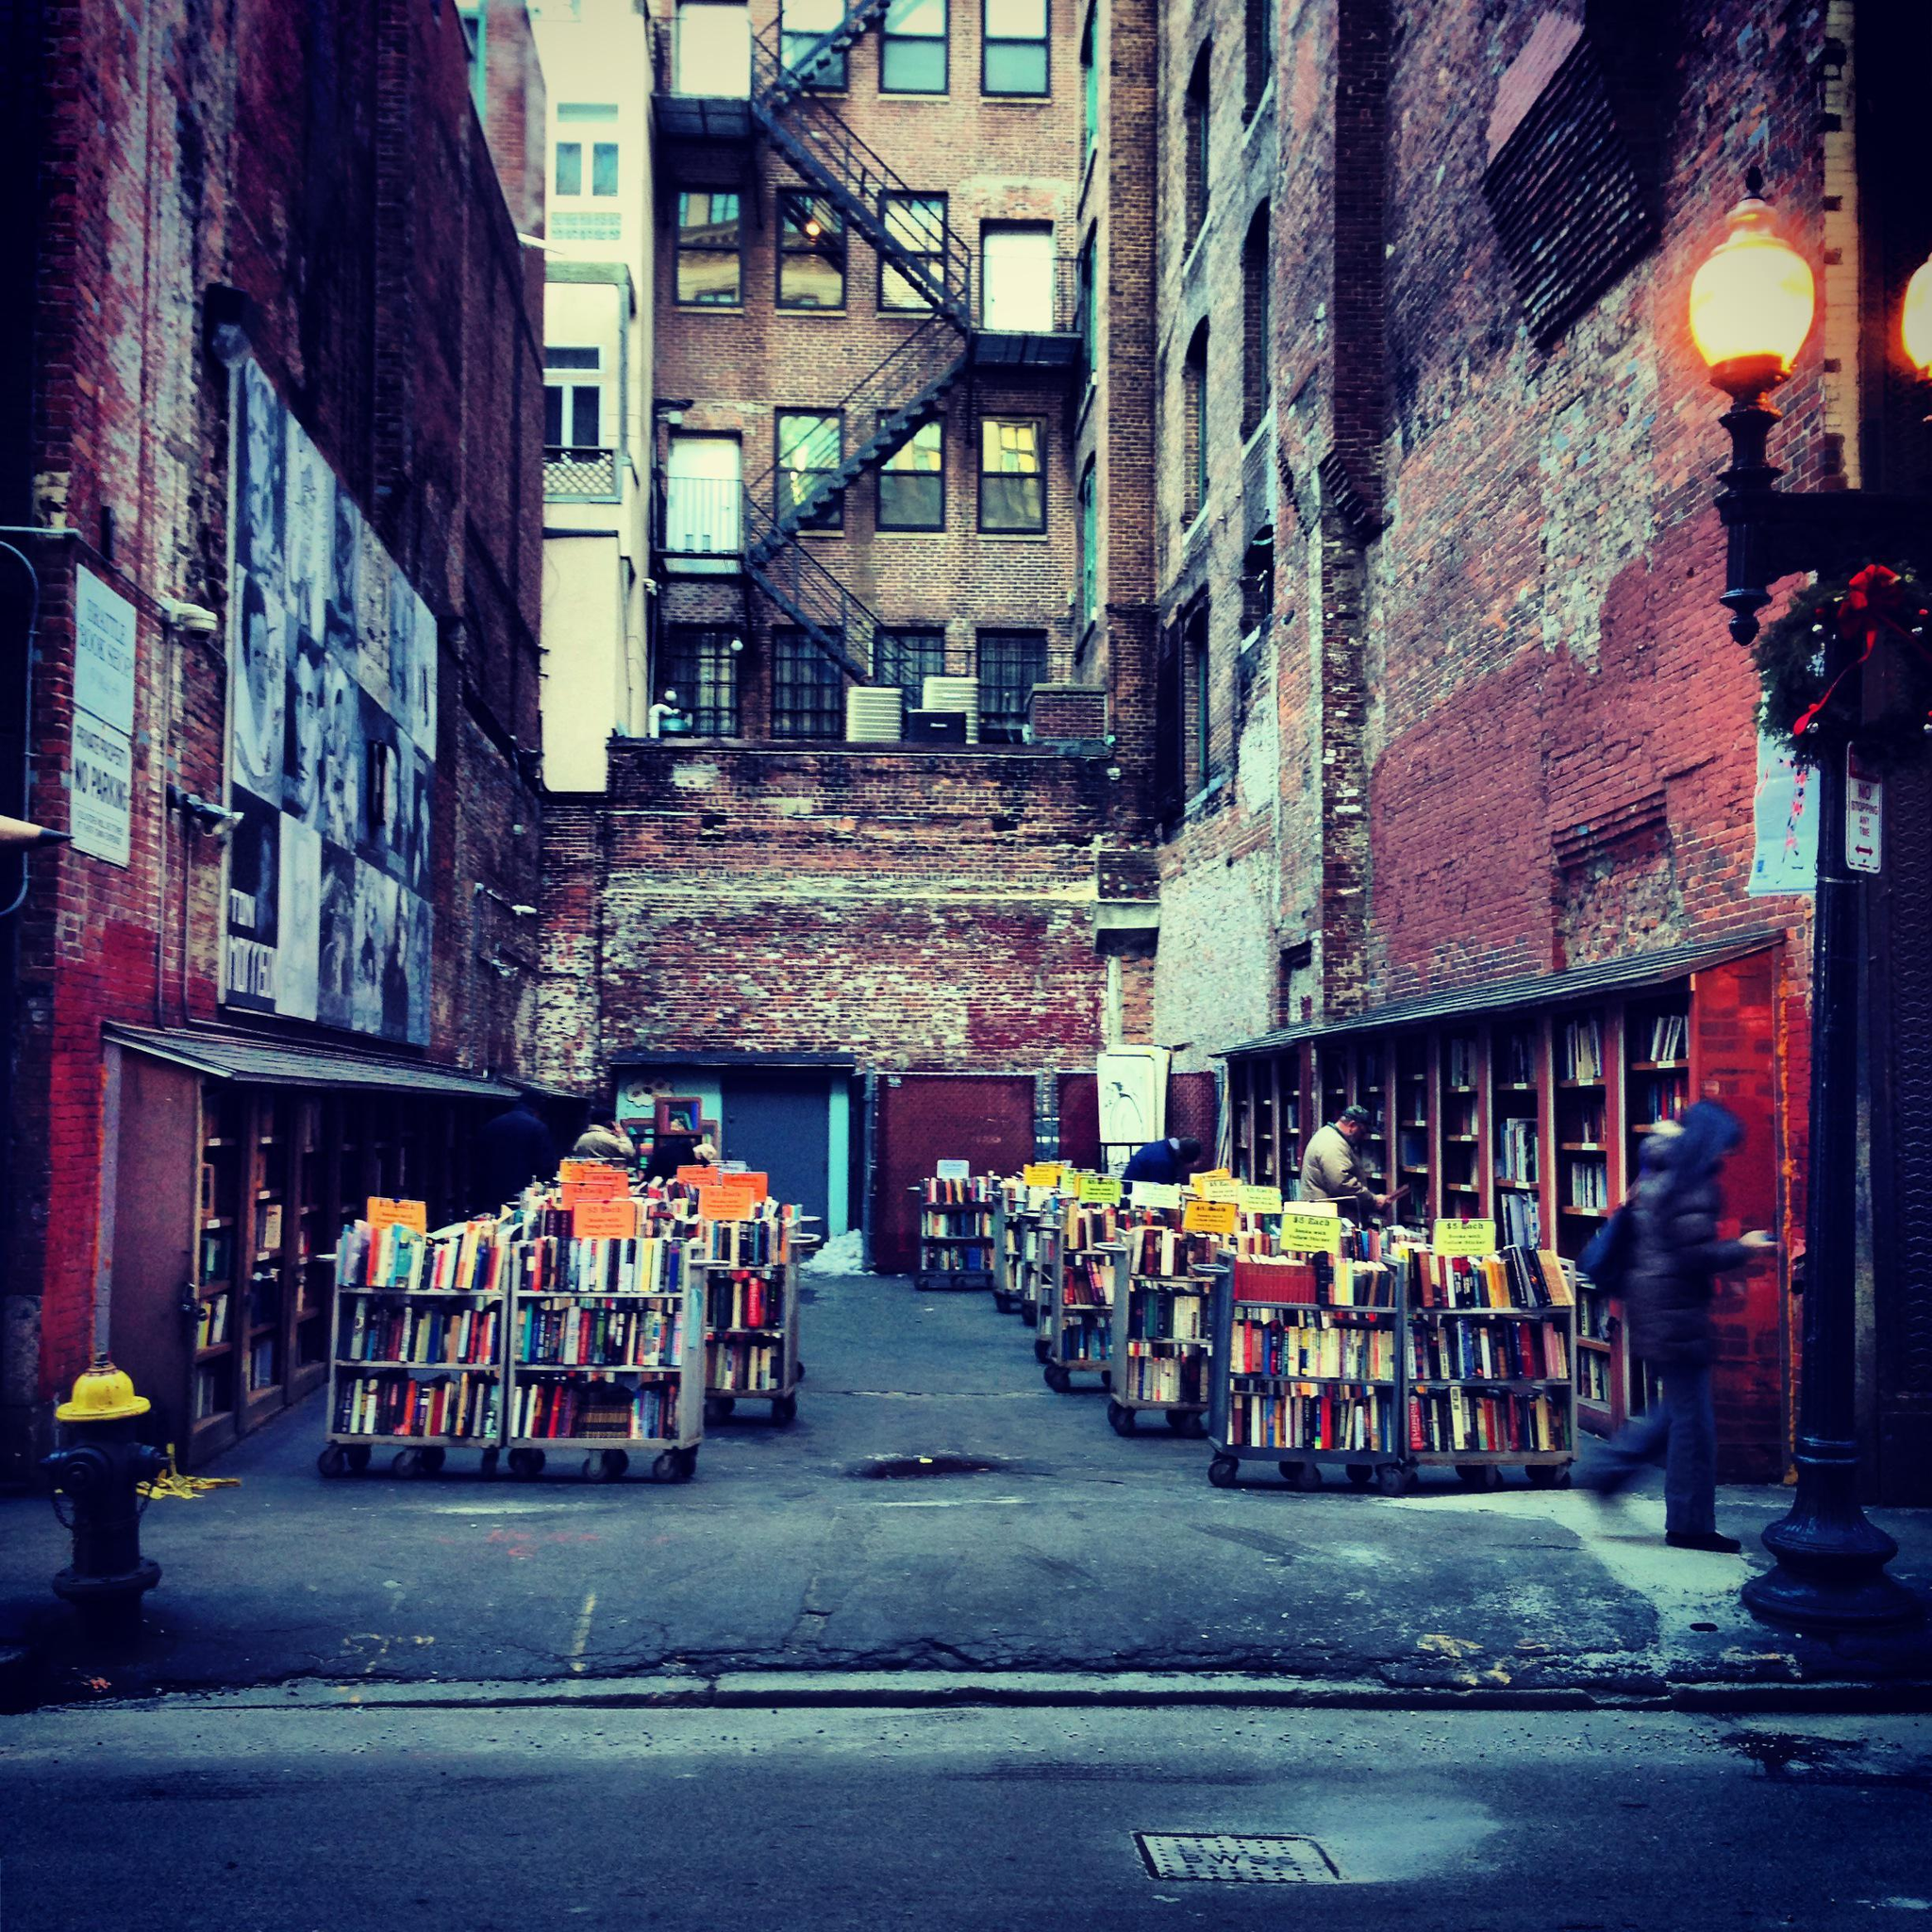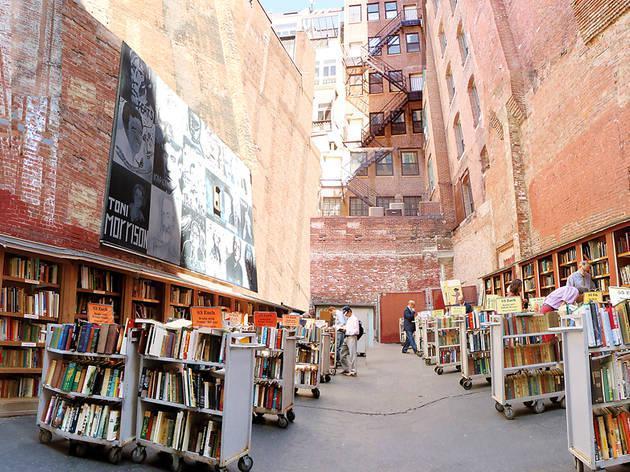The first image is the image on the left, the second image is the image on the right. Considering the images on both sides, is "A light sits on a pole on the street." valid? Answer yes or no. Yes. The first image is the image on the left, the second image is the image on the right. Evaluate the accuracy of this statement regarding the images: "stairs can be seen in the image on the left". Is it true? Answer yes or no. Yes. 